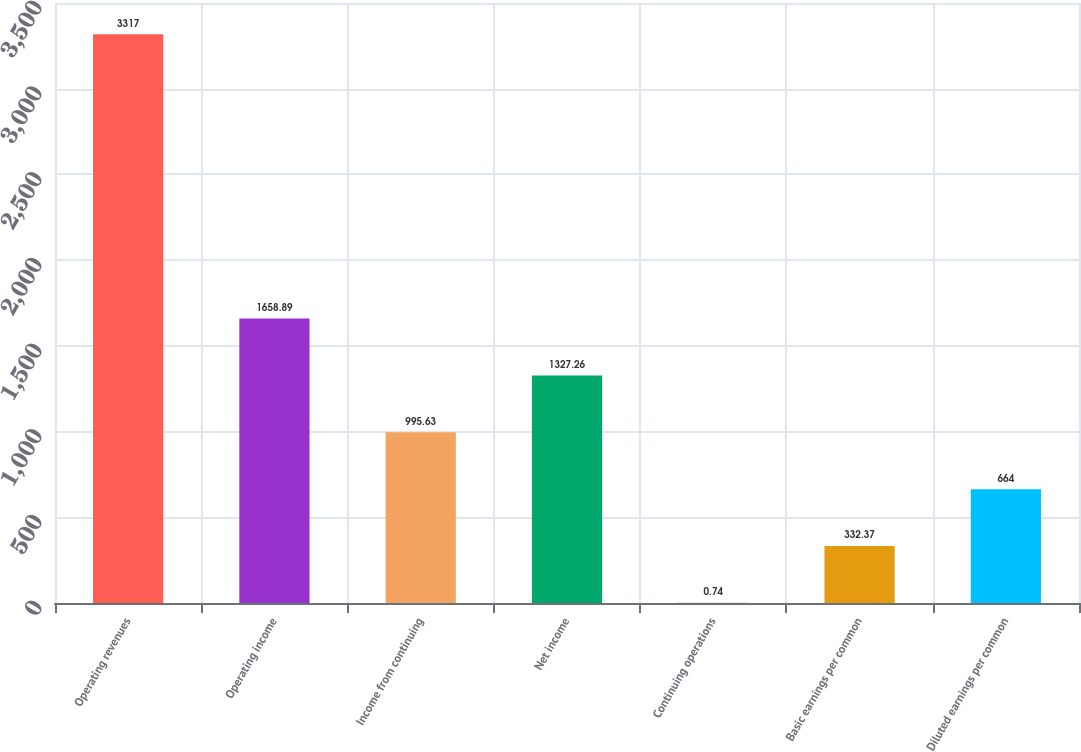Convert chart. <chart><loc_0><loc_0><loc_500><loc_500><bar_chart><fcel>Operating revenues<fcel>Operating income<fcel>Income from continuing<fcel>Net income<fcel>Continuing operations<fcel>Basic earnings per common<fcel>Diluted earnings per common<nl><fcel>3317<fcel>1658.89<fcel>995.63<fcel>1327.26<fcel>0.74<fcel>332.37<fcel>664<nl></chart> 